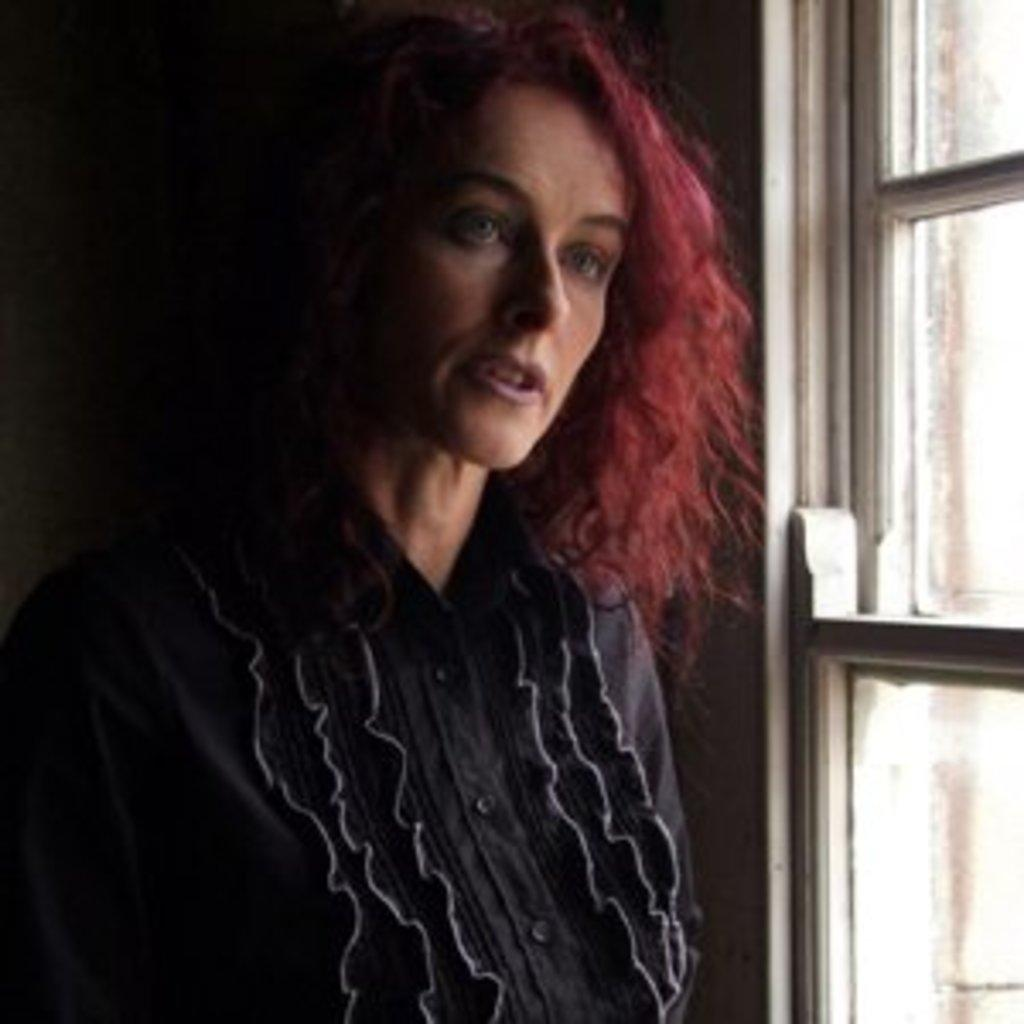Who is present in the image? There is a lady in the image. What is the lady doing in the image? The lady is standing beside a glass window. What type of form is the lady filling out in the image? There is no form present in the image; the lady is standing beside a glass window. How many steps does the lady take in the image? The lady is not taking any steps in the image; she is standing beside a glass window. 